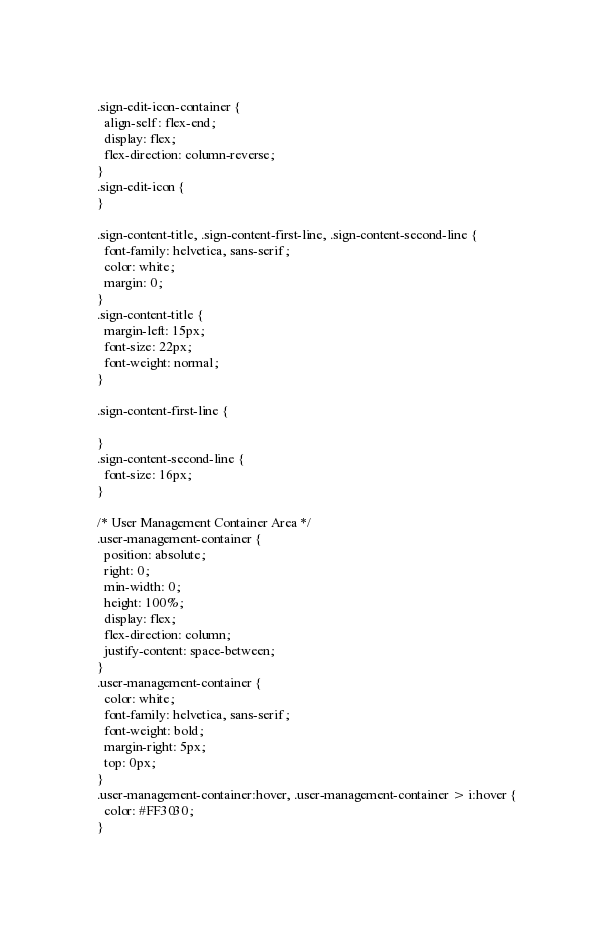<code> <loc_0><loc_0><loc_500><loc_500><_CSS_>.sign-edit-icon-container {
  align-self: flex-end;
  display: flex;
  flex-direction: column-reverse;
}
.sign-edit-icon {
}

.sign-content-title, .sign-content-first-line, .sign-content-second-line {
  font-family: helvetica, sans-serif;
  color: white;
  margin: 0;
}
.sign-content-title {
  margin-left: 15px;
  font-size: 22px;
  font-weight: normal;
}

.sign-content-first-line {

}
.sign-content-second-line {
  font-size: 16px;
}

/* User Management Container Area */
.user-management-container {
  position: absolute;
  right: 0;
  min-width: 0;
  height: 100%;
  display: flex;
  flex-direction: column;
  justify-content: space-between;
}
.user-management-container {
  color: white;
  font-family: helvetica, sans-serif;
  font-weight: bold;
  margin-right: 5px;
  top: 0px;
}
.user-management-container:hover, .user-management-container > i:hover {
  color: #FF3030;
}
</code> 